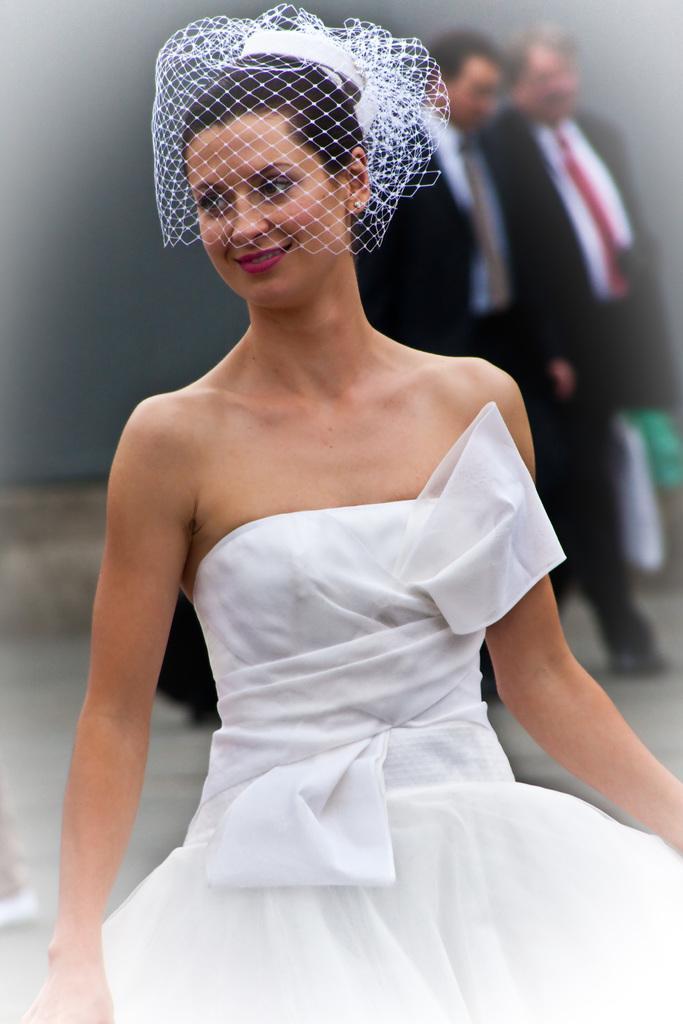How would you summarize this image in a sentence or two? In this picture we can see a woman wore a white dress, veil and smiling and at the back of her we can see some objects and two men wore blazers, ties and in the background we can see the wall. 